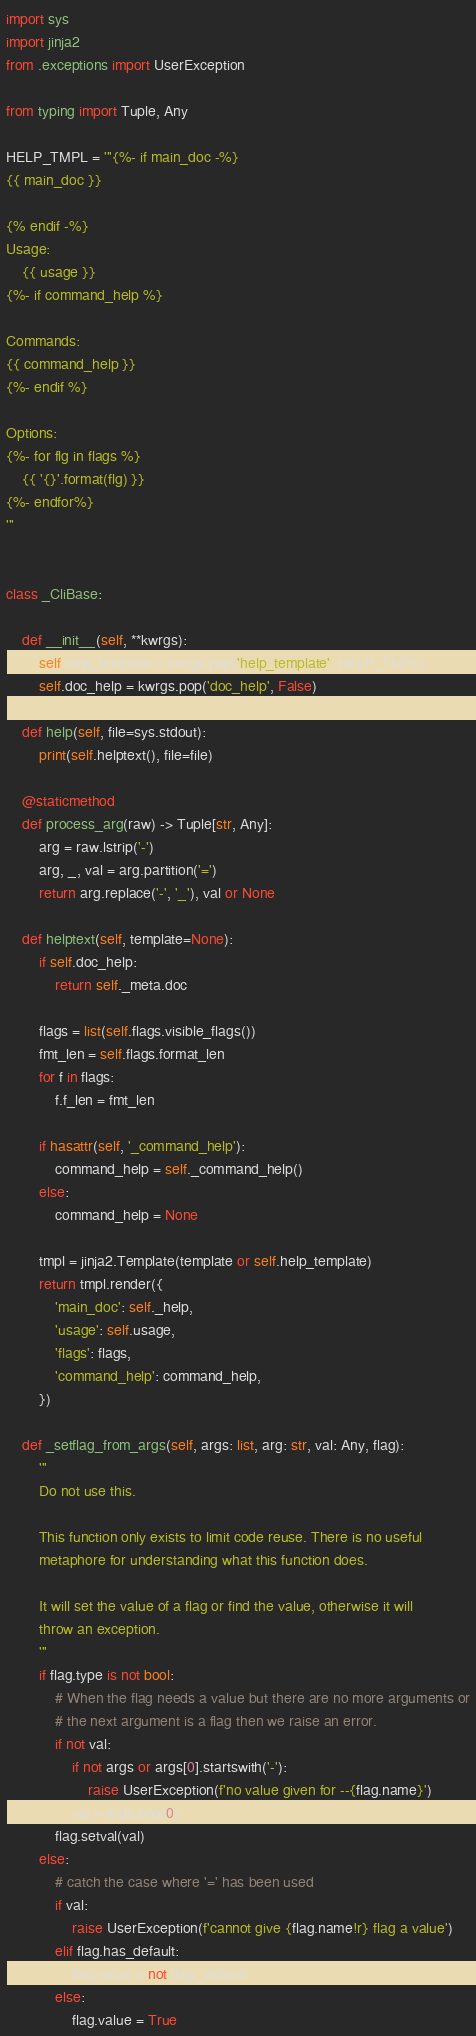<code> <loc_0><loc_0><loc_500><loc_500><_Python_>import sys
import jinja2
from .exceptions import UserException

from typing import Tuple, Any

HELP_TMPL = '''{%- if main_doc -%}
{{ main_doc }}

{% endif -%}
Usage:
    {{ usage }}
{%- if command_help %}

Commands:
{{ command_help }}
{%- endif %}

Options:
{%- for flg in flags %}
    {{ '{}'.format(flg) }}
{%- endfor%}
'''


class _CliBase:

    def __init__(self, **kwrgs):
        self.help_template = kwrgs.pop('help_template', HELP_TMPL)
        self.doc_help = kwrgs.pop('doc_help', False)

    def help(self, file=sys.stdout):
        print(self.helptext(), file=file)

    @staticmethod
    def process_arg(raw) -> Tuple[str, Any]:
        arg = raw.lstrip('-')
        arg, _, val = arg.partition('=')
        return arg.replace('-', '_'), val or None

    def helptext(self, template=None):
        if self.doc_help:
            return self._meta.doc

        flags = list(self.flags.visible_flags())
        fmt_len = self.flags.format_len
        for f in flags:
            f.f_len = fmt_len

        if hasattr(self, '_command_help'):
            command_help = self._command_help()
        else:
            command_help = None

        tmpl = jinja2.Template(template or self.help_template)
        return tmpl.render({
            'main_doc': self._help,
            'usage': self.usage,
            'flags': flags,
            'command_help': command_help,
        })

    def _setflag_from_args(self, args: list, arg: str, val: Any, flag):
        '''
        Do not use this.

        This function only exists to limit code reuse. There is no useful
        metaphore for understanding what this function does.

        It will set the value of a flag or find the value, otherwise it will
        throw an exception.
        '''
        if flag.type is not bool:
            # When the flag needs a value but there are no more arguments or
            # the next argument is a flag then we raise an error.
            if not val:
                if not args or args[0].startswith('-'):
                    raise UserException(f'no value given for --{flag.name}')
                val = args.pop(0)
            flag.setval(val)
        else:
            # catch the case where '=' has been used
            if val:
                raise UserException(f'cannot give {flag.name!r} flag a value')
            elif flag.has_default:
                flag.value = not flag._default
            else:
                flag.value = True</code> 